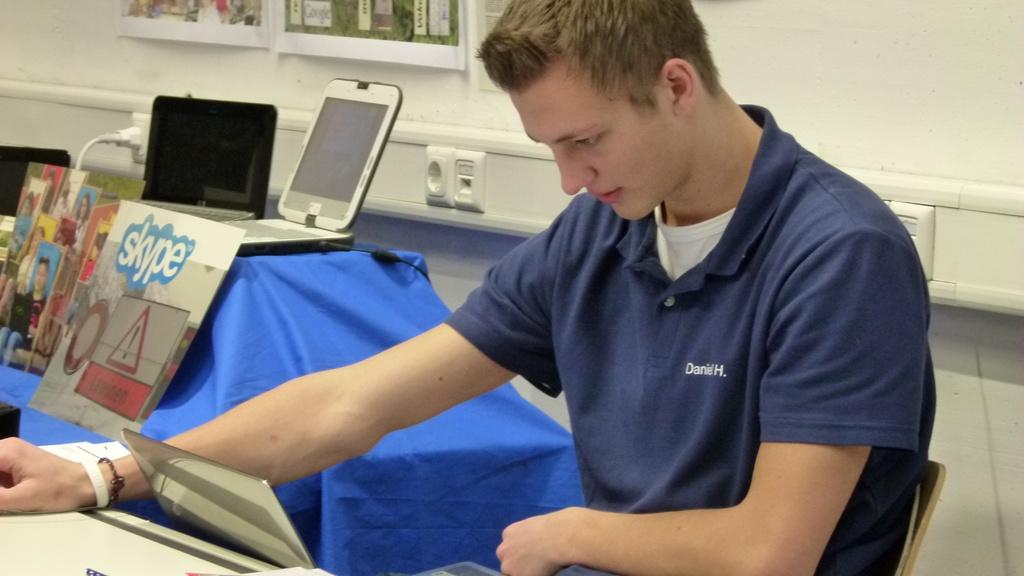<image>
Create a compact narrative representing the image presented. Daniel H. is sitting down in front of a laptop. 